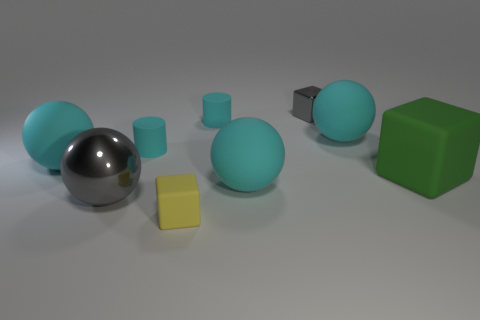The thing that is the same color as the large metallic ball is what shape?
Provide a short and direct response. Cube. There is a gray metal block; does it have the same size as the object that is in front of the large metal object?
Provide a succinct answer. Yes. How many objects are either purple metallic cylinders or small gray metallic things?
Ensure brevity in your answer.  1. Are there any small red things made of the same material as the gray ball?
Give a very brief answer. No. What is the size of the other metal thing that is the same color as the small metallic object?
Your answer should be very brief. Large. The sphere on the right side of the cyan matte sphere in front of the large green thing is what color?
Offer a very short reply. Cyan. Do the yellow rubber thing and the metal sphere have the same size?
Your response must be concise. No. How many balls are big green objects or tiny matte things?
Offer a very short reply. 0. There is a small gray metal thing right of the large gray thing; how many large gray metallic things are behind it?
Keep it short and to the point. 0. Does the big metallic object have the same shape as the large green rubber thing?
Give a very brief answer. No. 